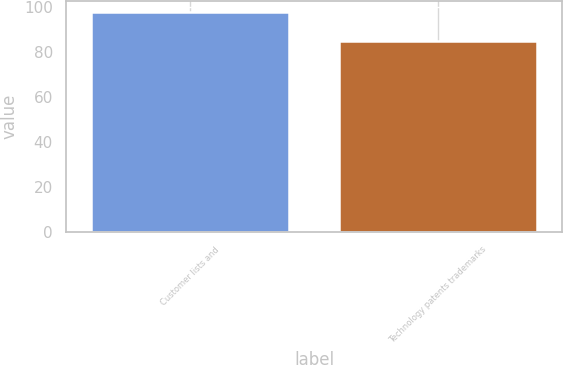Convert chart to OTSL. <chart><loc_0><loc_0><loc_500><loc_500><bar_chart><fcel>Customer lists and<fcel>Technology patents trademarks<nl><fcel>98<fcel>85<nl></chart> 